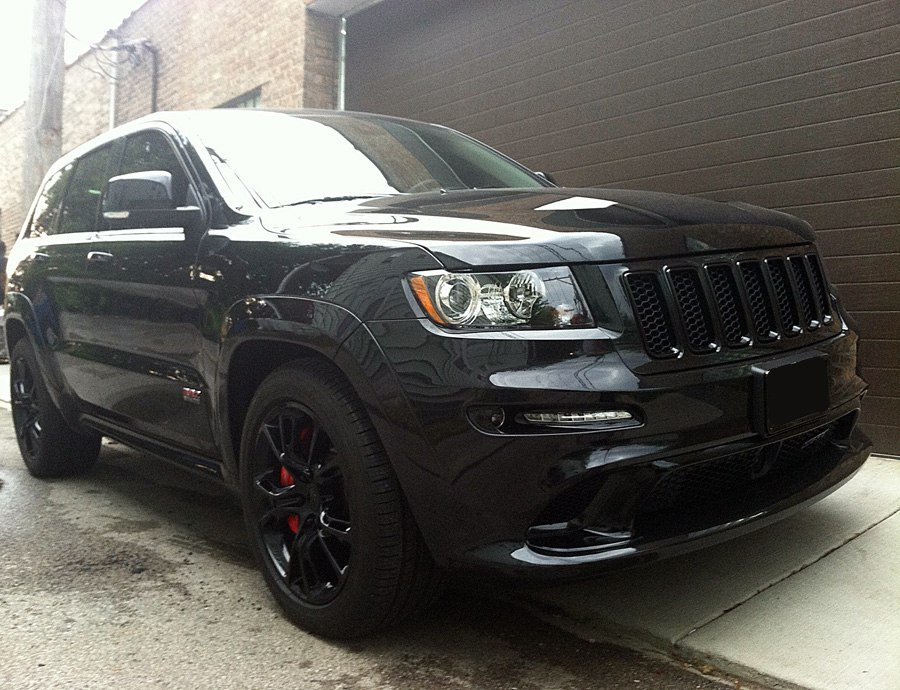What kind of modifications could be made to enhance this SUV’s off-road capabilities? To enhance this SUV's off-road capabilities, several modifications can be made. Firstly, swapping the low-profile tires for all-terrain or mud-terrain tires would significantly improve grip and performance on uneven surfaces. Adding a suspension lift kit would provide additional ground clearance, allowing the vehicle to navigate over rocks, debris, and other obstacles without damaging the undercarriage. Reinforcing the underbody with skid plates can offer protection against rough terrain. Upgrading to a heavy-duty suspension system would also absorb shocks more effectively. Installing a snorkel can help the engine breathe while traversing through water, and adding a winch would be beneficial for recovery situations. With these modifications, the SUV would become a versatile machine capable of tackling a variety of challenging off-road environments. Imagine this SUV as a character in a futuristic, post-apocalyptic world. What role does it play? In a futuristic, post-apocalyptic world, this SUV transforms into a vital and trusted companion for a group of survivors. With reinforced armor plating, powerful spotlights mounted on the roof, and a formidable bull bar at the front, it becomes a mobile fortress navigating through desolate landscapes. The vehicle's advanced modifications, including solar panel arrays and a self-sustaining power unit, allow it to travel long distances without the need for refueling. It serves as both a transportation and defense unit, with its robust performance and off-road enhancements ensuring it can outrun marauders and cross treacherous terrains. Inside, it's equipped with essential supplies, communication devices, and compartments for weapons, making it a critical asset in the fight for survival. This SUV is not just a vehicle; it's a symbol of resilience and ingenuity in a world where only the strongest endure. If this SUV was to be used in a marketing campaign, what key features should be highlighted to attract potential buyers? In a marketing campaign for this SUV, key features to highlight should include its powerful performance capabilities, exemplified by the sleek five-spoke black wheels and striking red brake calipers that hint at an advanced braking system and sporty handling. Emphasize the luxurious and bold design, with a high-gloss black paint finish that exudes sophistication and modern appeal. Showcase its advanced interior technology, such as state-of-the-art infotainment systems, premium leather seating, and superior comfort features. Highlight the balance between performance and practicality, drawing attention to its versatile nature—capable of delivering an exhilarating driving experience while also meeting day-to-day needs with its spacious and well-crafted interior. Additionally, emphasize any safety features, such as advanced driver-assistance systems, to appeal to buyers looking for both style and reliability. 